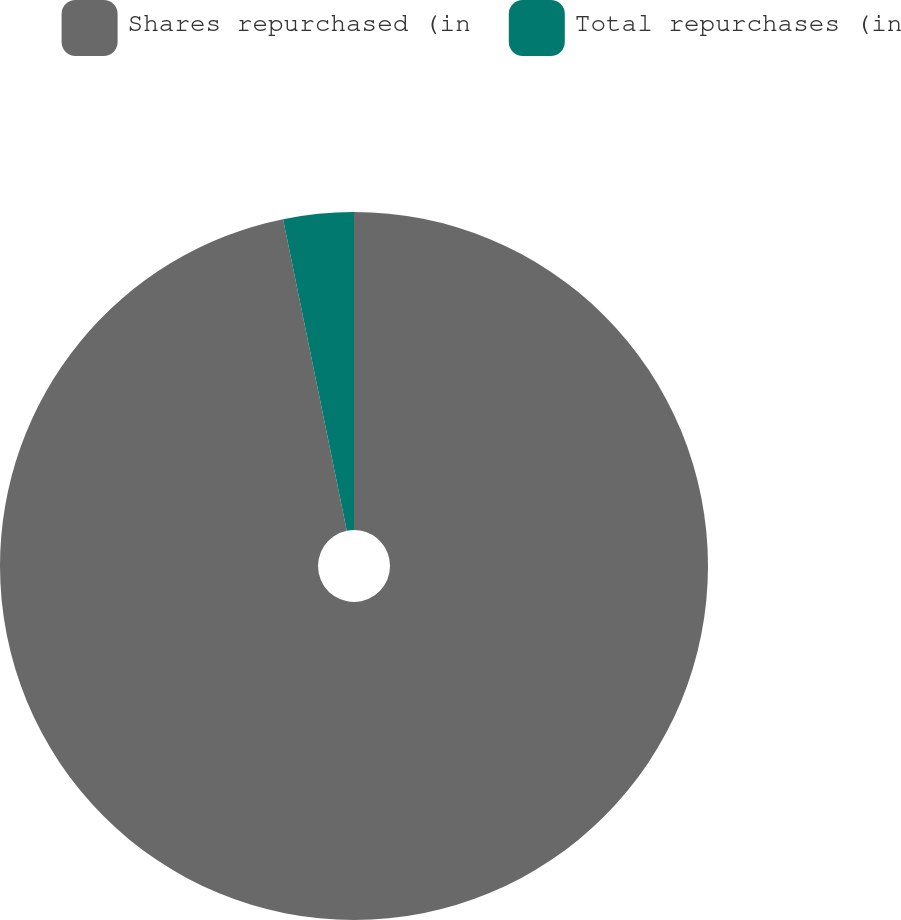Convert chart to OTSL. <chart><loc_0><loc_0><loc_500><loc_500><pie_chart><fcel>Shares repurchased (in<fcel>Total repurchases (in<nl><fcel>96.79%<fcel>3.21%<nl></chart> 